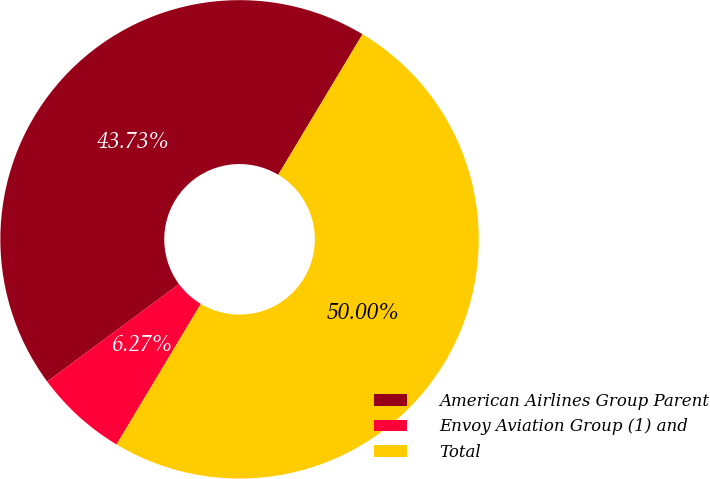Convert chart to OTSL. <chart><loc_0><loc_0><loc_500><loc_500><pie_chart><fcel>American Airlines Group Parent<fcel>Envoy Aviation Group (1) and<fcel>Total<nl><fcel>43.73%<fcel>6.27%<fcel>50.0%<nl></chart> 